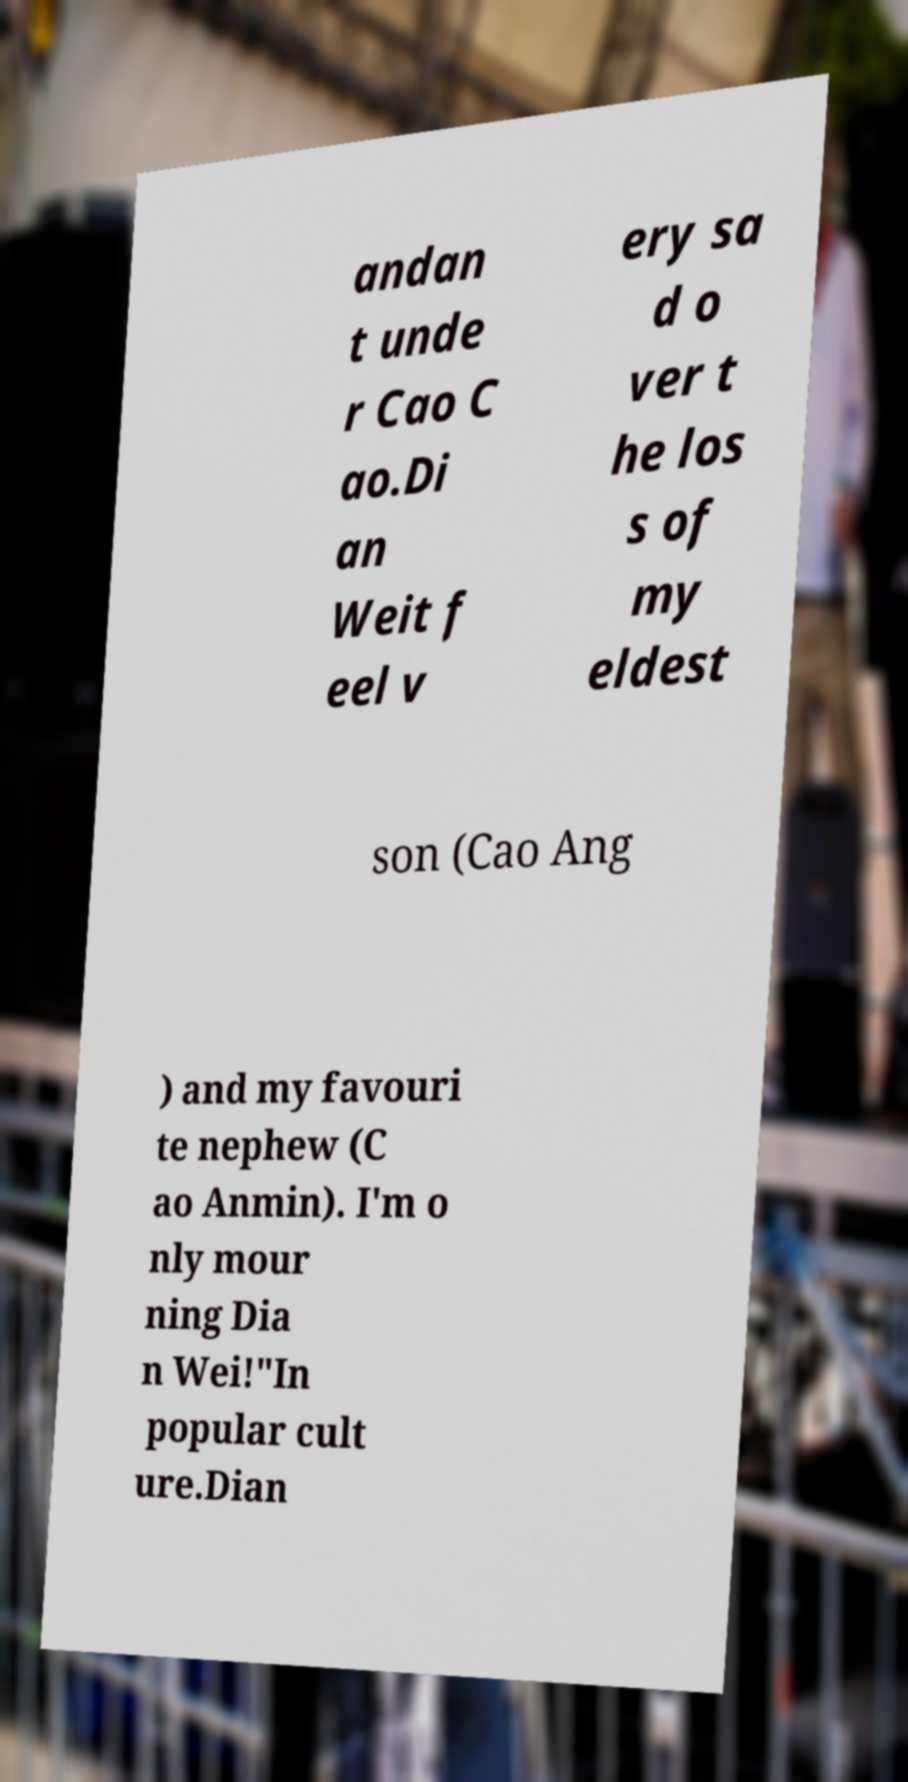Please identify and transcribe the text found in this image. andan t unde r Cao C ao.Di an Weit f eel v ery sa d o ver t he los s of my eldest son (Cao Ang ) and my favouri te nephew (C ao Anmin). I'm o nly mour ning Dia n Wei!"In popular cult ure.Dian 